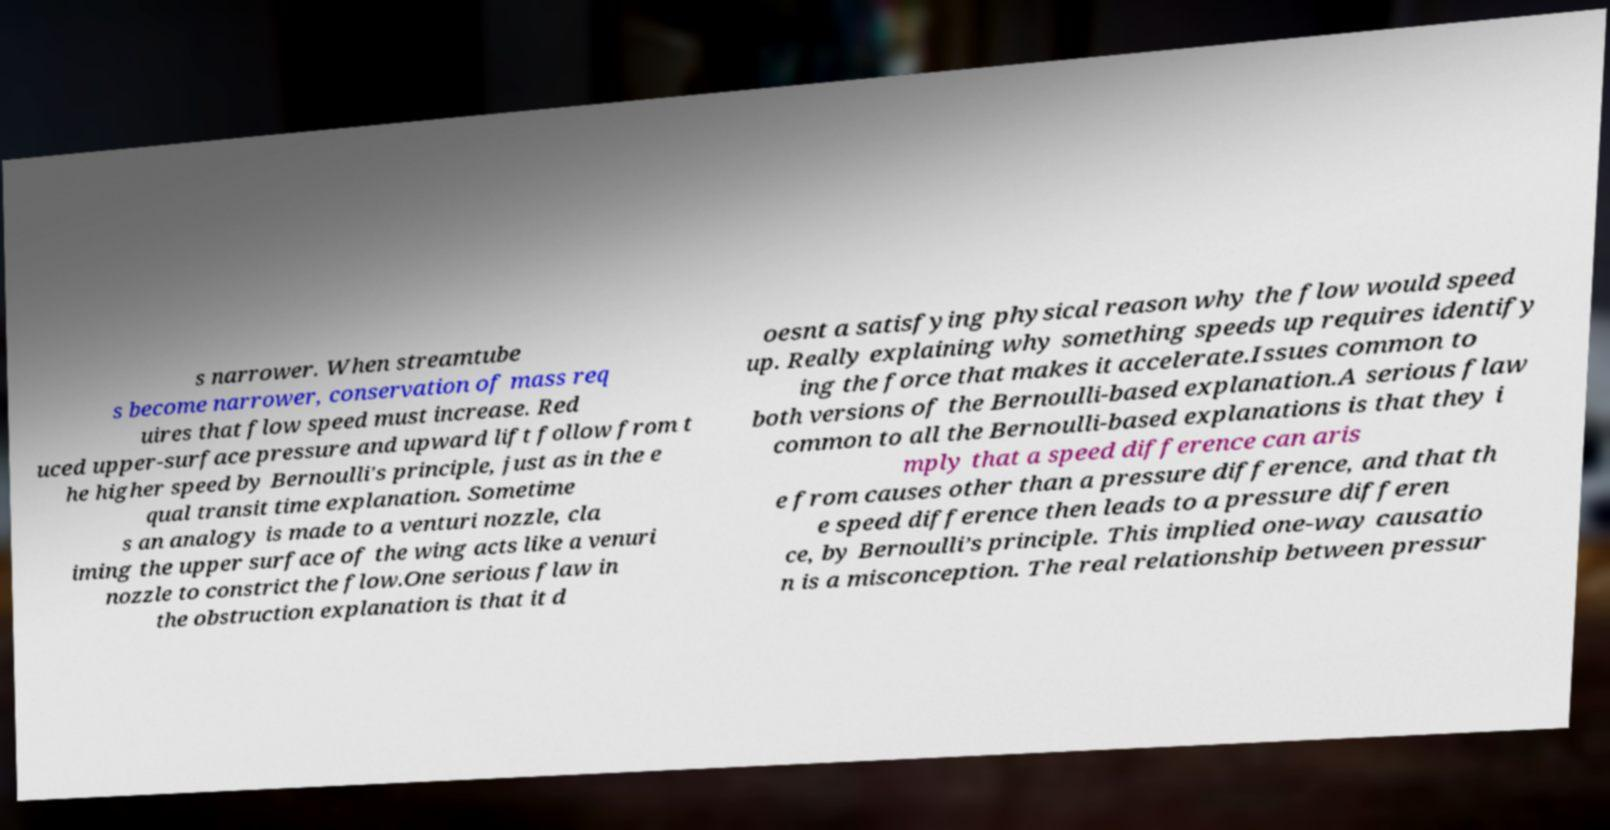Please read and relay the text visible in this image. What does it say? s narrower. When streamtube s become narrower, conservation of mass req uires that flow speed must increase. Red uced upper-surface pressure and upward lift follow from t he higher speed by Bernoulli's principle, just as in the e qual transit time explanation. Sometime s an analogy is made to a venturi nozzle, cla iming the upper surface of the wing acts like a venuri nozzle to constrict the flow.One serious flaw in the obstruction explanation is that it d oesnt a satisfying physical reason why the flow would speed up. Really explaining why something speeds up requires identify ing the force that makes it accelerate.Issues common to both versions of the Bernoulli-based explanation.A serious flaw common to all the Bernoulli-based explanations is that they i mply that a speed difference can aris e from causes other than a pressure difference, and that th e speed difference then leads to a pressure differen ce, by Bernoulli’s principle. This implied one-way causatio n is a misconception. The real relationship between pressur 